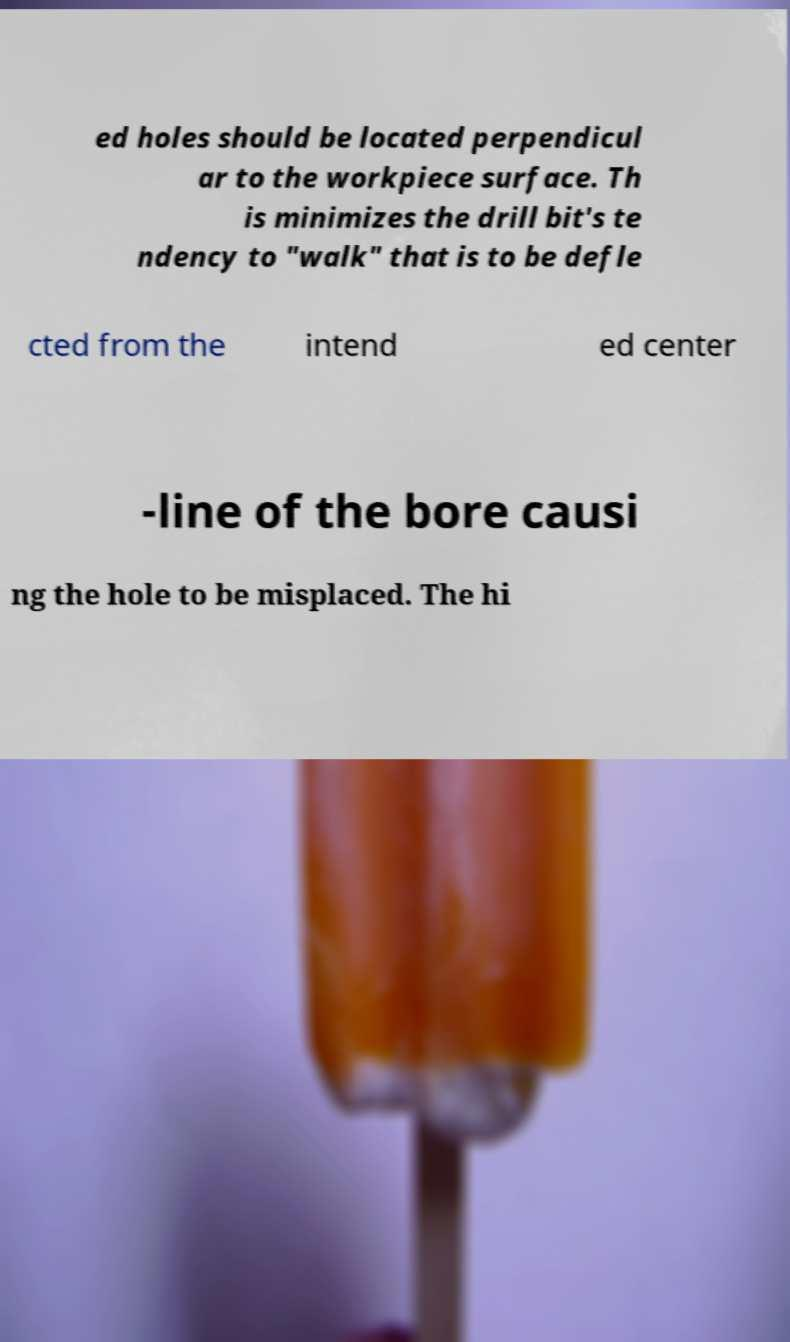Could you assist in decoding the text presented in this image and type it out clearly? ed holes should be located perpendicul ar to the workpiece surface. Th is minimizes the drill bit's te ndency to "walk" that is to be defle cted from the intend ed center -line of the bore causi ng the hole to be misplaced. The hi 